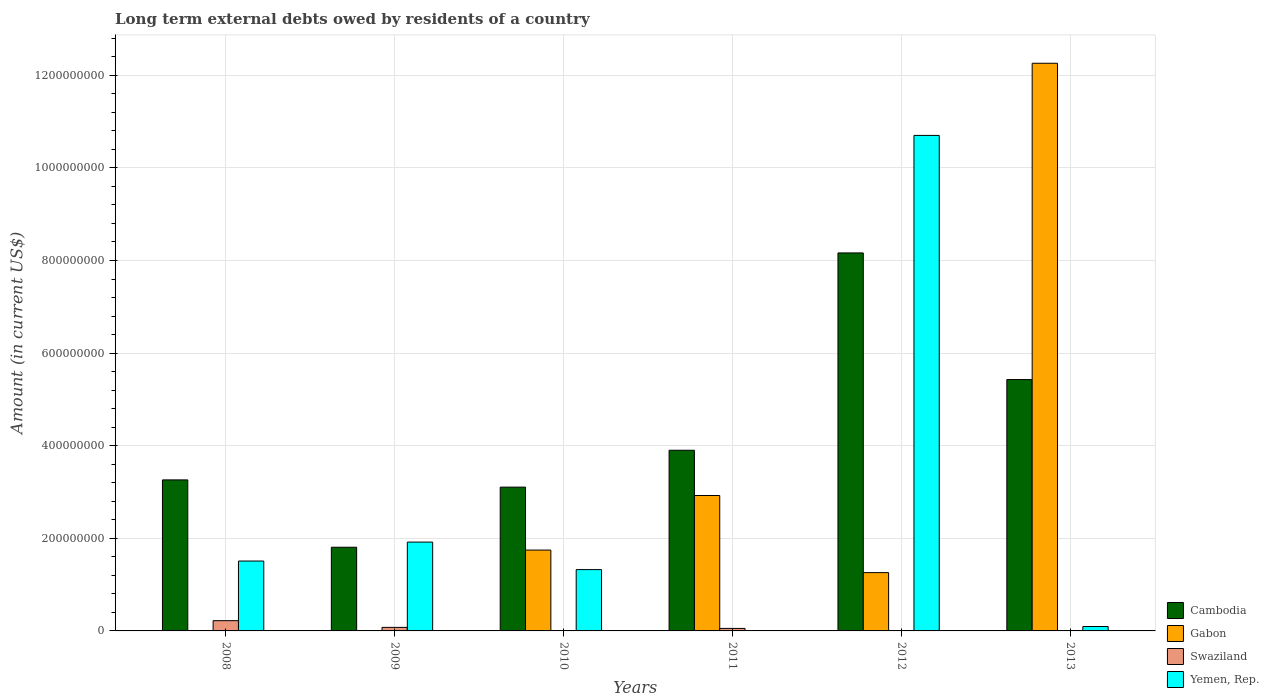How many different coloured bars are there?
Your response must be concise. 4. Are the number of bars per tick equal to the number of legend labels?
Your answer should be compact. No. What is the label of the 6th group of bars from the left?
Provide a short and direct response. 2013. In how many cases, is the number of bars for a given year not equal to the number of legend labels?
Ensure brevity in your answer.  5. Across all years, what is the maximum amount of long-term external debts owed by residents in Cambodia?
Your response must be concise. 8.16e+08. In which year was the amount of long-term external debts owed by residents in Yemen, Rep. maximum?
Make the answer very short. 2012. What is the total amount of long-term external debts owed by residents in Yemen, Rep. in the graph?
Your answer should be very brief. 1.55e+09. What is the difference between the amount of long-term external debts owed by residents in Cambodia in 2011 and that in 2013?
Offer a terse response. -1.53e+08. What is the difference between the amount of long-term external debts owed by residents in Swaziland in 2009 and the amount of long-term external debts owed by residents in Yemen, Rep. in 2012?
Your answer should be very brief. -1.06e+09. What is the average amount of long-term external debts owed by residents in Yemen, Rep. per year?
Your response must be concise. 2.59e+08. In the year 2008, what is the difference between the amount of long-term external debts owed by residents in Yemen, Rep. and amount of long-term external debts owed by residents in Swaziland?
Your response must be concise. 1.29e+08. What is the ratio of the amount of long-term external debts owed by residents in Cambodia in 2011 to that in 2012?
Make the answer very short. 0.48. Is the amount of long-term external debts owed by residents in Swaziland in 2008 less than that in 2009?
Provide a short and direct response. No. What is the difference between the highest and the second highest amount of long-term external debts owed by residents in Cambodia?
Ensure brevity in your answer.  2.73e+08. What is the difference between the highest and the lowest amount of long-term external debts owed by residents in Cambodia?
Ensure brevity in your answer.  6.36e+08. In how many years, is the amount of long-term external debts owed by residents in Swaziland greater than the average amount of long-term external debts owed by residents in Swaziland taken over all years?
Offer a terse response. 2. Is the sum of the amount of long-term external debts owed by residents in Gabon in 2010 and 2012 greater than the maximum amount of long-term external debts owed by residents in Yemen, Rep. across all years?
Your answer should be compact. No. Is it the case that in every year, the sum of the amount of long-term external debts owed by residents in Gabon and amount of long-term external debts owed by residents in Swaziland is greater than the sum of amount of long-term external debts owed by residents in Yemen, Rep. and amount of long-term external debts owed by residents in Cambodia?
Provide a succinct answer. Yes. Is it the case that in every year, the sum of the amount of long-term external debts owed by residents in Yemen, Rep. and amount of long-term external debts owed by residents in Cambodia is greater than the amount of long-term external debts owed by residents in Gabon?
Make the answer very short. No. How many bars are there?
Make the answer very short. 19. Are all the bars in the graph horizontal?
Your response must be concise. No. How many years are there in the graph?
Give a very brief answer. 6. Does the graph contain any zero values?
Make the answer very short. Yes. Does the graph contain grids?
Offer a terse response. Yes. How are the legend labels stacked?
Give a very brief answer. Vertical. What is the title of the graph?
Give a very brief answer. Long term external debts owed by residents of a country. Does "Liberia" appear as one of the legend labels in the graph?
Provide a succinct answer. No. What is the Amount (in current US$) in Cambodia in 2008?
Offer a very short reply. 3.26e+08. What is the Amount (in current US$) in Gabon in 2008?
Offer a very short reply. 0. What is the Amount (in current US$) of Swaziland in 2008?
Your answer should be compact. 2.21e+07. What is the Amount (in current US$) in Yemen, Rep. in 2008?
Your answer should be very brief. 1.51e+08. What is the Amount (in current US$) of Cambodia in 2009?
Your response must be concise. 1.81e+08. What is the Amount (in current US$) in Gabon in 2009?
Make the answer very short. 2.35e+05. What is the Amount (in current US$) in Swaziland in 2009?
Make the answer very short. 7.65e+06. What is the Amount (in current US$) of Yemen, Rep. in 2009?
Provide a succinct answer. 1.92e+08. What is the Amount (in current US$) in Cambodia in 2010?
Keep it short and to the point. 3.11e+08. What is the Amount (in current US$) in Gabon in 2010?
Your answer should be compact. 1.75e+08. What is the Amount (in current US$) in Yemen, Rep. in 2010?
Your response must be concise. 1.32e+08. What is the Amount (in current US$) in Cambodia in 2011?
Give a very brief answer. 3.90e+08. What is the Amount (in current US$) of Gabon in 2011?
Offer a terse response. 2.92e+08. What is the Amount (in current US$) in Swaziland in 2011?
Keep it short and to the point. 5.42e+06. What is the Amount (in current US$) in Yemen, Rep. in 2011?
Make the answer very short. 0. What is the Amount (in current US$) of Cambodia in 2012?
Keep it short and to the point. 8.16e+08. What is the Amount (in current US$) of Gabon in 2012?
Keep it short and to the point. 1.26e+08. What is the Amount (in current US$) in Swaziland in 2012?
Provide a short and direct response. 0. What is the Amount (in current US$) in Yemen, Rep. in 2012?
Provide a succinct answer. 1.07e+09. What is the Amount (in current US$) in Cambodia in 2013?
Make the answer very short. 5.43e+08. What is the Amount (in current US$) in Gabon in 2013?
Keep it short and to the point. 1.23e+09. What is the Amount (in current US$) of Yemen, Rep. in 2013?
Ensure brevity in your answer.  9.54e+06. Across all years, what is the maximum Amount (in current US$) in Cambodia?
Your answer should be very brief. 8.16e+08. Across all years, what is the maximum Amount (in current US$) of Gabon?
Make the answer very short. 1.23e+09. Across all years, what is the maximum Amount (in current US$) in Swaziland?
Provide a succinct answer. 2.21e+07. Across all years, what is the maximum Amount (in current US$) of Yemen, Rep.?
Your response must be concise. 1.07e+09. Across all years, what is the minimum Amount (in current US$) of Cambodia?
Give a very brief answer. 1.81e+08. Across all years, what is the minimum Amount (in current US$) in Gabon?
Your response must be concise. 0. Across all years, what is the minimum Amount (in current US$) of Yemen, Rep.?
Provide a short and direct response. 0. What is the total Amount (in current US$) in Cambodia in the graph?
Offer a terse response. 2.57e+09. What is the total Amount (in current US$) of Gabon in the graph?
Your response must be concise. 1.82e+09. What is the total Amount (in current US$) in Swaziland in the graph?
Offer a terse response. 3.52e+07. What is the total Amount (in current US$) of Yemen, Rep. in the graph?
Keep it short and to the point. 1.55e+09. What is the difference between the Amount (in current US$) of Cambodia in 2008 and that in 2009?
Offer a very short reply. 1.45e+08. What is the difference between the Amount (in current US$) in Swaziland in 2008 and that in 2009?
Ensure brevity in your answer.  1.45e+07. What is the difference between the Amount (in current US$) in Yemen, Rep. in 2008 and that in 2009?
Keep it short and to the point. -4.09e+07. What is the difference between the Amount (in current US$) of Cambodia in 2008 and that in 2010?
Your answer should be compact. 1.56e+07. What is the difference between the Amount (in current US$) of Yemen, Rep. in 2008 and that in 2010?
Offer a very short reply. 1.85e+07. What is the difference between the Amount (in current US$) of Cambodia in 2008 and that in 2011?
Give a very brief answer. -6.40e+07. What is the difference between the Amount (in current US$) in Swaziland in 2008 and that in 2011?
Make the answer very short. 1.67e+07. What is the difference between the Amount (in current US$) in Cambodia in 2008 and that in 2012?
Keep it short and to the point. -4.90e+08. What is the difference between the Amount (in current US$) in Yemen, Rep. in 2008 and that in 2012?
Make the answer very short. -9.19e+08. What is the difference between the Amount (in current US$) of Cambodia in 2008 and that in 2013?
Provide a succinct answer. -2.17e+08. What is the difference between the Amount (in current US$) in Yemen, Rep. in 2008 and that in 2013?
Provide a short and direct response. 1.41e+08. What is the difference between the Amount (in current US$) in Cambodia in 2009 and that in 2010?
Ensure brevity in your answer.  -1.30e+08. What is the difference between the Amount (in current US$) of Gabon in 2009 and that in 2010?
Provide a succinct answer. -1.74e+08. What is the difference between the Amount (in current US$) in Yemen, Rep. in 2009 and that in 2010?
Provide a succinct answer. 5.94e+07. What is the difference between the Amount (in current US$) of Cambodia in 2009 and that in 2011?
Offer a very short reply. -2.09e+08. What is the difference between the Amount (in current US$) in Gabon in 2009 and that in 2011?
Your answer should be compact. -2.92e+08. What is the difference between the Amount (in current US$) in Swaziland in 2009 and that in 2011?
Ensure brevity in your answer.  2.23e+06. What is the difference between the Amount (in current US$) of Cambodia in 2009 and that in 2012?
Ensure brevity in your answer.  -6.36e+08. What is the difference between the Amount (in current US$) in Gabon in 2009 and that in 2012?
Offer a very short reply. -1.26e+08. What is the difference between the Amount (in current US$) in Yemen, Rep. in 2009 and that in 2012?
Make the answer very short. -8.78e+08. What is the difference between the Amount (in current US$) of Cambodia in 2009 and that in 2013?
Your answer should be compact. -3.62e+08. What is the difference between the Amount (in current US$) in Gabon in 2009 and that in 2013?
Ensure brevity in your answer.  -1.23e+09. What is the difference between the Amount (in current US$) of Yemen, Rep. in 2009 and that in 2013?
Your answer should be very brief. 1.82e+08. What is the difference between the Amount (in current US$) of Cambodia in 2010 and that in 2011?
Ensure brevity in your answer.  -7.97e+07. What is the difference between the Amount (in current US$) in Gabon in 2010 and that in 2011?
Your answer should be compact. -1.18e+08. What is the difference between the Amount (in current US$) of Cambodia in 2010 and that in 2012?
Your answer should be compact. -5.06e+08. What is the difference between the Amount (in current US$) in Gabon in 2010 and that in 2012?
Make the answer very short. 4.87e+07. What is the difference between the Amount (in current US$) in Yemen, Rep. in 2010 and that in 2012?
Your response must be concise. -9.38e+08. What is the difference between the Amount (in current US$) of Cambodia in 2010 and that in 2013?
Provide a succinct answer. -2.32e+08. What is the difference between the Amount (in current US$) of Gabon in 2010 and that in 2013?
Your response must be concise. -1.05e+09. What is the difference between the Amount (in current US$) of Yemen, Rep. in 2010 and that in 2013?
Keep it short and to the point. 1.23e+08. What is the difference between the Amount (in current US$) in Cambodia in 2011 and that in 2012?
Offer a very short reply. -4.26e+08. What is the difference between the Amount (in current US$) in Gabon in 2011 and that in 2012?
Offer a very short reply. 1.67e+08. What is the difference between the Amount (in current US$) in Cambodia in 2011 and that in 2013?
Offer a terse response. -1.53e+08. What is the difference between the Amount (in current US$) of Gabon in 2011 and that in 2013?
Your answer should be compact. -9.34e+08. What is the difference between the Amount (in current US$) of Cambodia in 2012 and that in 2013?
Provide a short and direct response. 2.73e+08. What is the difference between the Amount (in current US$) of Gabon in 2012 and that in 2013?
Offer a terse response. -1.10e+09. What is the difference between the Amount (in current US$) in Yemen, Rep. in 2012 and that in 2013?
Offer a very short reply. 1.06e+09. What is the difference between the Amount (in current US$) of Cambodia in 2008 and the Amount (in current US$) of Gabon in 2009?
Keep it short and to the point. 3.26e+08. What is the difference between the Amount (in current US$) in Cambodia in 2008 and the Amount (in current US$) in Swaziland in 2009?
Provide a succinct answer. 3.19e+08. What is the difference between the Amount (in current US$) in Cambodia in 2008 and the Amount (in current US$) in Yemen, Rep. in 2009?
Give a very brief answer. 1.34e+08. What is the difference between the Amount (in current US$) of Swaziland in 2008 and the Amount (in current US$) of Yemen, Rep. in 2009?
Provide a short and direct response. -1.70e+08. What is the difference between the Amount (in current US$) in Cambodia in 2008 and the Amount (in current US$) in Gabon in 2010?
Give a very brief answer. 1.52e+08. What is the difference between the Amount (in current US$) of Cambodia in 2008 and the Amount (in current US$) of Yemen, Rep. in 2010?
Offer a very short reply. 1.94e+08. What is the difference between the Amount (in current US$) of Swaziland in 2008 and the Amount (in current US$) of Yemen, Rep. in 2010?
Offer a very short reply. -1.10e+08. What is the difference between the Amount (in current US$) in Cambodia in 2008 and the Amount (in current US$) in Gabon in 2011?
Ensure brevity in your answer.  3.37e+07. What is the difference between the Amount (in current US$) of Cambodia in 2008 and the Amount (in current US$) of Swaziland in 2011?
Give a very brief answer. 3.21e+08. What is the difference between the Amount (in current US$) of Cambodia in 2008 and the Amount (in current US$) of Gabon in 2012?
Offer a very short reply. 2.00e+08. What is the difference between the Amount (in current US$) in Cambodia in 2008 and the Amount (in current US$) in Yemen, Rep. in 2012?
Provide a succinct answer. -7.44e+08. What is the difference between the Amount (in current US$) of Swaziland in 2008 and the Amount (in current US$) of Yemen, Rep. in 2012?
Give a very brief answer. -1.05e+09. What is the difference between the Amount (in current US$) in Cambodia in 2008 and the Amount (in current US$) in Gabon in 2013?
Your response must be concise. -9.00e+08. What is the difference between the Amount (in current US$) of Cambodia in 2008 and the Amount (in current US$) of Yemen, Rep. in 2013?
Make the answer very short. 3.17e+08. What is the difference between the Amount (in current US$) in Swaziland in 2008 and the Amount (in current US$) in Yemen, Rep. in 2013?
Keep it short and to the point. 1.26e+07. What is the difference between the Amount (in current US$) in Cambodia in 2009 and the Amount (in current US$) in Gabon in 2010?
Ensure brevity in your answer.  6.11e+06. What is the difference between the Amount (in current US$) in Cambodia in 2009 and the Amount (in current US$) in Yemen, Rep. in 2010?
Your answer should be compact. 4.83e+07. What is the difference between the Amount (in current US$) of Gabon in 2009 and the Amount (in current US$) of Yemen, Rep. in 2010?
Offer a very short reply. -1.32e+08. What is the difference between the Amount (in current US$) of Swaziland in 2009 and the Amount (in current US$) of Yemen, Rep. in 2010?
Your answer should be compact. -1.25e+08. What is the difference between the Amount (in current US$) of Cambodia in 2009 and the Amount (in current US$) of Gabon in 2011?
Offer a very short reply. -1.12e+08. What is the difference between the Amount (in current US$) in Cambodia in 2009 and the Amount (in current US$) in Swaziland in 2011?
Give a very brief answer. 1.75e+08. What is the difference between the Amount (in current US$) in Gabon in 2009 and the Amount (in current US$) in Swaziland in 2011?
Your response must be concise. -5.18e+06. What is the difference between the Amount (in current US$) in Cambodia in 2009 and the Amount (in current US$) in Gabon in 2012?
Your answer should be compact. 5.48e+07. What is the difference between the Amount (in current US$) in Cambodia in 2009 and the Amount (in current US$) in Yemen, Rep. in 2012?
Give a very brief answer. -8.89e+08. What is the difference between the Amount (in current US$) of Gabon in 2009 and the Amount (in current US$) of Yemen, Rep. in 2012?
Give a very brief answer. -1.07e+09. What is the difference between the Amount (in current US$) in Swaziland in 2009 and the Amount (in current US$) in Yemen, Rep. in 2012?
Your answer should be compact. -1.06e+09. What is the difference between the Amount (in current US$) of Cambodia in 2009 and the Amount (in current US$) of Gabon in 2013?
Your answer should be very brief. -1.05e+09. What is the difference between the Amount (in current US$) of Cambodia in 2009 and the Amount (in current US$) of Yemen, Rep. in 2013?
Make the answer very short. 1.71e+08. What is the difference between the Amount (in current US$) of Gabon in 2009 and the Amount (in current US$) of Yemen, Rep. in 2013?
Your answer should be compact. -9.31e+06. What is the difference between the Amount (in current US$) of Swaziland in 2009 and the Amount (in current US$) of Yemen, Rep. in 2013?
Offer a terse response. -1.89e+06. What is the difference between the Amount (in current US$) of Cambodia in 2010 and the Amount (in current US$) of Gabon in 2011?
Offer a terse response. 1.81e+07. What is the difference between the Amount (in current US$) in Cambodia in 2010 and the Amount (in current US$) in Swaziland in 2011?
Give a very brief answer. 3.05e+08. What is the difference between the Amount (in current US$) in Gabon in 2010 and the Amount (in current US$) in Swaziland in 2011?
Ensure brevity in your answer.  1.69e+08. What is the difference between the Amount (in current US$) in Cambodia in 2010 and the Amount (in current US$) in Gabon in 2012?
Keep it short and to the point. 1.85e+08. What is the difference between the Amount (in current US$) of Cambodia in 2010 and the Amount (in current US$) of Yemen, Rep. in 2012?
Your answer should be compact. -7.60e+08. What is the difference between the Amount (in current US$) of Gabon in 2010 and the Amount (in current US$) of Yemen, Rep. in 2012?
Your answer should be very brief. -8.96e+08. What is the difference between the Amount (in current US$) in Cambodia in 2010 and the Amount (in current US$) in Gabon in 2013?
Keep it short and to the point. -9.15e+08. What is the difference between the Amount (in current US$) in Cambodia in 2010 and the Amount (in current US$) in Yemen, Rep. in 2013?
Your answer should be compact. 3.01e+08. What is the difference between the Amount (in current US$) of Gabon in 2010 and the Amount (in current US$) of Yemen, Rep. in 2013?
Give a very brief answer. 1.65e+08. What is the difference between the Amount (in current US$) of Cambodia in 2011 and the Amount (in current US$) of Gabon in 2012?
Your answer should be very brief. 2.64e+08. What is the difference between the Amount (in current US$) in Cambodia in 2011 and the Amount (in current US$) in Yemen, Rep. in 2012?
Offer a very short reply. -6.80e+08. What is the difference between the Amount (in current US$) in Gabon in 2011 and the Amount (in current US$) in Yemen, Rep. in 2012?
Provide a succinct answer. -7.78e+08. What is the difference between the Amount (in current US$) in Swaziland in 2011 and the Amount (in current US$) in Yemen, Rep. in 2012?
Your response must be concise. -1.06e+09. What is the difference between the Amount (in current US$) of Cambodia in 2011 and the Amount (in current US$) of Gabon in 2013?
Offer a very short reply. -8.36e+08. What is the difference between the Amount (in current US$) of Cambodia in 2011 and the Amount (in current US$) of Yemen, Rep. in 2013?
Make the answer very short. 3.81e+08. What is the difference between the Amount (in current US$) in Gabon in 2011 and the Amount (in current US$) in Yemen, Rep. in 2013?
Keep it short and to the point. 2.83e+08. What is the difference between the Amount (in current US$) of Swaziland in 2011 and the Amount (in current US$) of Yemen, Rep. in 2013?
Give a very brief answer. -4.12e+06. What is the difference between the Amount (in current US$) of Cambodia in 2012 and the Amount (in current US$) of Gabon in 2013?
Provide a succinct answer. -4.10e+08. What is the difference between the Amount (in current US$) in Cambodia in 2012 and the Amount (in current US$) in Yemen, Rep. in 2013?
Provide a short and direct response. 8.07e+08. What is the difference between the Amount (in current US$) of Gabon in 2012 and the Amount (in current US$) of Yemen, Rep. in 2013?
Provide a succinct answer. 1.16e+08. What is the average Amount (in current US$) in Cambodia per year?
Provide a succinct answer. 4.28e+08. What is the average Amount (in current US$) in Gabon per year?
Offer a very short reply. 3.03e+08. What is the average Amount (in current US$) of Swaziland per year?
Provide a succinct answer. 5.87e+06. What is the average Amount (in current US$) in Yemen, Rep. per year?
Offer a terse response. 2.59e+08. In the year 2008, what is the difference between the Amount (in current US$) in Cambodia and Amount (in current US$) in Swaziland?
Your response must be concise. 3.04e+08. In the year 2008, what is the difference between the Amount (in current US$) of Cambodia and Amount (in current US$) of Yemen, Rep.?
Your answer should be very brief. 1.75e+08. In the year 2008, what is the difference between the Amount (in current US$) of Swaziland and Amount (in current US$) of Yemen, Rep.?
Offer a terse response. -1.29e+08. In the year 2009, what is the difference between the Amount (in current US$) of Cambodia and Amount (in current US$) of Gabon?
Offer a very short reply. 1.80e+08. In the year 2009, what is the difference between the Amount (in current US$) of Cambodia and Amount (in current US$) of Swaziland?
Ensure brevity in your answer.  1.73e+08. In the year 2009, what is the difference between the Amount (in current US$) in Cambodia and Amount (in current US$) in Yemen, Rep.?
Keep it short and to the point. -1.11e+07. In the year 2009, what is the difference between the Amount (in current US$) in Gabon and Amount (in current US$) in Swaziland?
Make the answer very short. -7.42e+06. In the year 2009, what is the difference between the Amount (in current US$) of Gabon and Amount (in current US$) of Yemen, Rep.?
Your response must be concise. -1.92e+08. In the year 2009, what is the difference between the Amount (in current US$) in Swaziland and Amount (in current US$) in Yemen, Rep.?
Make the answer very short. -1.84e+08. In the year 2010, what is the difference between the Amount (in current US$) of Cambodia and Amount (in current US$) of Gabon?
Offer a terse response. 1.36e+08. In the year 2010, what is the difference between the Amount (in current US$) in Cambodia and Amount (in current US$) in Yemen, Rep.?
Provide a short and direct response. 1.78e+08. In the year 2010, what is the difference between the Amount (in current US$) of Gabon and Amount (in current US$) of Yemen, Rep.?
Make the answer very short. 4.22e+07. In the year 2011, what is the difference between the Amount (in current US$) in Cambodia and Amount (in current US$) in Gabon?
Your response must be concise. 9.78e+07. In the year 2011, what is the difference between the Amount (in current US$) of Cambodia and Amount (in current US$) of Swaziland?
Make the answer very short. 3.85e+08. In the year 2011, what is the difference between the Amount (in current US$) of Gabon and Amount (in current US$) of Swaziland?
Offer a terse response. 2.87e+08. In the year 2012, what is the difference between the Amount (in current US$) of Cambodia and Amount (in current US$) of Gabon?
Ensure brevity in your answer.  6.90e+08. In the year 2012, what is the difference between the Amount (in current US$) in Cambodia and Amount (in current US$) in Yemen, Rep.?
Provide a short and direct response. -2.54e+08. In the year 2012, what is the difference between the Amount (in current US$) in Gabon and Amount (in current US$) in Yemen, Rep.?
Keep it short and to the point. -9.44e+08. In the year 2013, what is the difference between the Amount (in current US$) of Cambodia and Amount (in current US$) of Gabon?
Offer a very short reply. -6.83e+08. In the year 2013, what is the difference between the Amount (in current US$) of Cambodia and Amount (in current US$) of Yemen, Rep.?
Offer a very short reply. 5.33e+08. In the year 2013, what is the difference between the Amount (in current US$) of Gabon and Amount (in current US$) of Yemen, Rep.?
Give a very brief answer. 1.22e+09. What is the ratio of the Amount (in current US$) in Cambodia in 2008 to that in 2009?
Your answer should be compact. 1.8. What is the ratio of the Amount (in current US$) in Swaziland in 2008 to that in 2009?
Give a very brief answer. 2.89. What is the ratio of the Amount (in current US$) in Yemen, Rep. in 2008 to that in 2009?
Your response must be concise. 0.79. What is the ratio of the Amount (in current US$) in Cambodia in 2008 to that in 2010?
Keep it short and to the point. 1.05. What is the ratio of the Amount (in current US$) in Yemen, Rep. in 2008 to that in 2010?
Provide a succinct answer. 1.14. What is the ratio of the Amount (in current US$) of Cambodia in 2008 to that in 2011?
Your answer should be very brief. 0.84. What is the ratio of the Amount (in current US$) in Swaziland in 2008 to that in 2011?
Provide a short and direct response. 4.08. What is the ratio of the Amount (in current US$) of Cambodia in 2008 to that in 2012?
Provide a succinct answer. 0.4. What is the ratio of the Amount (in current US$) in Yemen, Rep. in 2008 to that in 2012?
Your answer should be very brief. 0.14. What is the ratio of the Amount (in current US$) in Cambodia in 2008 to that in 2013?
Offer a very short reply. 0.6. What is the ratio of the Amount (in current US$) in Yemen, Rep. in 2008 to that in 2013?
Your answer should be very brief. 15.82. What is the ratio of the Amount (in current US$) in Cambodia in 2009 to that in 2010?
Make the answer very short. 0.58. What is the ratio of the Amount (in current US$) of Gabon in 2009 to that in 2010?
Provide a short and direct response. 0. What is the ratio of the Amount (in current US$) of Yemen, Rep. in 2009 to that in 2010?
Keep it short and to the point. 1.45. What is the ratio of the Amount (in current US$) in Cambodia in 2009 to that in 2011?
Offer a very short reply. 0.46. What is the ratio of the Amount (in current US$) of Gabon in 2009 to that in 2011?
Ensure brevity in your answer.  0. What is the ratio of the Amount (in current US$) in Swaziland in 2009 to that in 2011?
Provide a short and direct response. 1.41. What is the ratio of the Amount (in current US$) of Cambodia in 2009 to that in 2012?
Provide a succinct answer. 0.22. What is the ratio of the Amount (in current US$) in Gabon in 2009 to that in 2012?
Provide a short and direct response. 0. What is the ratio of the Amount (in current US$) in Yemen, Rep. in 2009 to that in 2012?
Provide a short and direct response. 0.18. What is the ratio of the Amount (in current US$) of Cambodia in 2009 to that in 2013?
Offer a terse response. 0.33. What is the ratio of the Amount (in current US$) in Yemen, Rep. in 2009 to that in 2013?
Keep it short and to the point. 20.11. What is the ratio of the Amount (in current US$) of Cambodia in 2010 to that in 2011?
Your answer should be compact. 0.8. What is the ratio of the Amount (in current US$) in Gabon in 2010 to that in 2011?
Make the answer very short. 0.6. What is the ratio of the Amount (in current US$) in Cambodia in 2010 to that in 2012?
Offer a very short reply. 0.38. What is the ratio of the Amount (in current US$) of Gabon in 2010 to that in 2012?
Provide a short and direct response. 1.39. What is the ratio of the Amount (in current US$) in Yemen, Rep. in 2010 to that in 2012?
Provide a succinct answer. 0.12. What is the ratio of the Amount (in current US$) of Cambodia in 2010 to that in 2013?
Ensure brevity in your answer.  0.57. What is the ratio of the Amount (in current US$) of Gabon in 2010 to that in 2013?
Make the answer very short. 0.14. What is the ratio of the Amount (in current US$) of Yemen, Rep. in 2010 to that in 2013?
Your answer should be compact. 13.88. What is the ratio of the Amount (in current US$) in Cambodia in 2011 to that in 2012?
Your response must be concise. 0.48. What is the ratio of the Amount (in current US$) of Gabon in 2011 to that in 2012?
Make the answer very short. 2.32. What is the ratio of the Amount (in current US$) in Cambodia in 2011 to that in 2013?
Your answer should be very brief. 0.72. What is the ratio of the Amount (in current US$) in Gabon in 2011 to that in 2013?
Keep it short and to the point. 0.24. What is the ratio of the Amount (in current US$) in Cambodia in 2012 to that in 2013?
Your answer should be very brief. 1.5. What is the ratio of the Amount (in current US$) in Gabon in 2012 to that in 2013?
Give a very brief answer. 0.1. What is the ratio of the Amount (in current US$) of Yemen, Rep. in 2012 to that in 2013?
Your answer should be very brief. 112.17. What is the difference between the highest and the second highest Amount (in current US$) of Cambodia?
Your answer should be compact. 2.73e+08. What is the difference between the highest and the second highest Amount (in current US$) in Gabon?
Ensure brevity in your answer.  9.34e+08. What is the difference between the highest and the second highest Amount (in current US$) in Swaziland?
Provide a short and direct response. 1.45e+07. What is the difference between the highest and the second highest Amount (in current US$) in Yemen, Rep.?
Your answer should be compact. 8.78e+08. What is the difference between the highest and the lowest Amount (in current US$) of Cambodia?
Provide a short and direct response. 6.36e+08. What is the difference between the highest and the lowest Amount (in current US$) of Gabon?
Your response must be concise. 1.23e+09. What is the difference between the highest and the lowest Amount (in current US$) in Swaziland?
Keep it short and to the point. 2.21e+07. What is the difference between the highest and the lowest Amount (in current US$) of Yemen, Rep.?
Provide a short and direct response. 1.07e+09. 